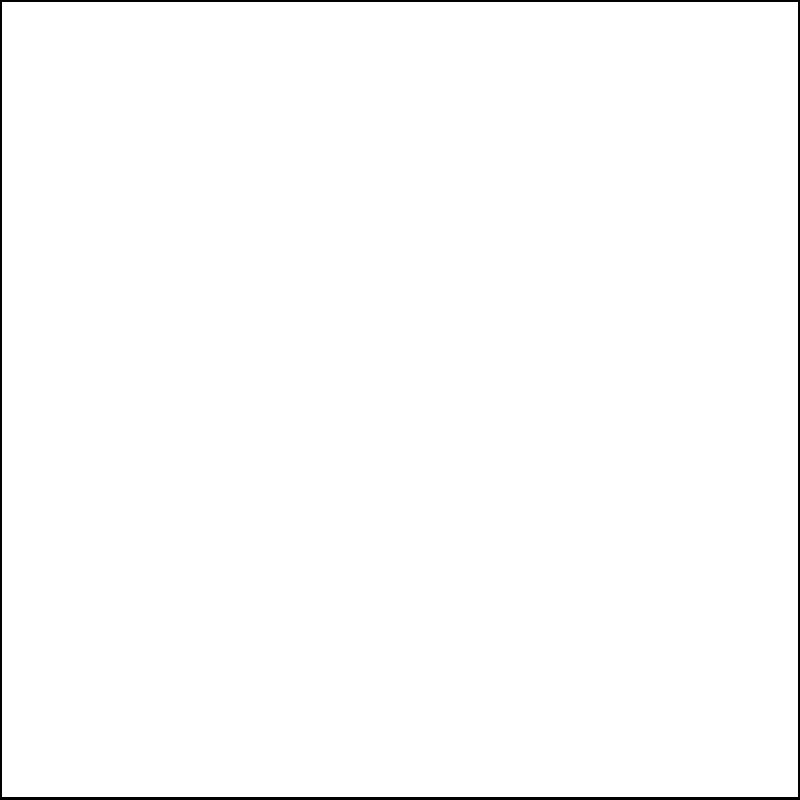A multinational organization wants to optimize the distribution of multilingual resources across Europe. The resource density at any point $(x,y)$ is given by the function $f(x,y) = 100e^{-0.0005((x-50)^2+(y-50)^2)}$, where $x$ and $y$ are measured in kilometers from the southwest corner of the map. Find the maximum resource density and its location. To find the maximum resource density and its location, we need to follow these steps:

1) The function $f(x,y) = 100e^{-0.0005((x-50)^2+(y-50)^2)}$ represents a two-variable Gaussian distribution centered at (50,50).

2) To find the maximum, we need to find the critical points by taking partial derivatives and setting them to zero:

   $\frac{\partial f}{\partial x} = -0.1((x-50))e^{-0.0005((x-50)^2+(y-50)^2)} = 0$
   $\frac{\partial f}{\partial y} = -0.1((y-50))e^{-0.0005((x-50)^2+(y-50)^2)} = 0$

3) These equations are satisfied when $x=50$ and $y=50$.

4) To confirm this is a maximum, we could check the second derivatives, but given the nature of the exponential function, we know this will be a global maximum.

5) The location of the maximum is therefore at (50,50) km from the southwest corner.

6) To find the maximum value, we substitute these coordinates back into the original function:

   $f(50,50) = 100e^{-0.0005((50-50)^2+(50-50)^2)} = 100e^0 = 100$

Therefore, the maximum resource density is 100 units per square kilometer, located at the point (50,50) km from the southwest corner of the map.
Answer: Maximum density: 100 units/km²; Location: (50,50) km 